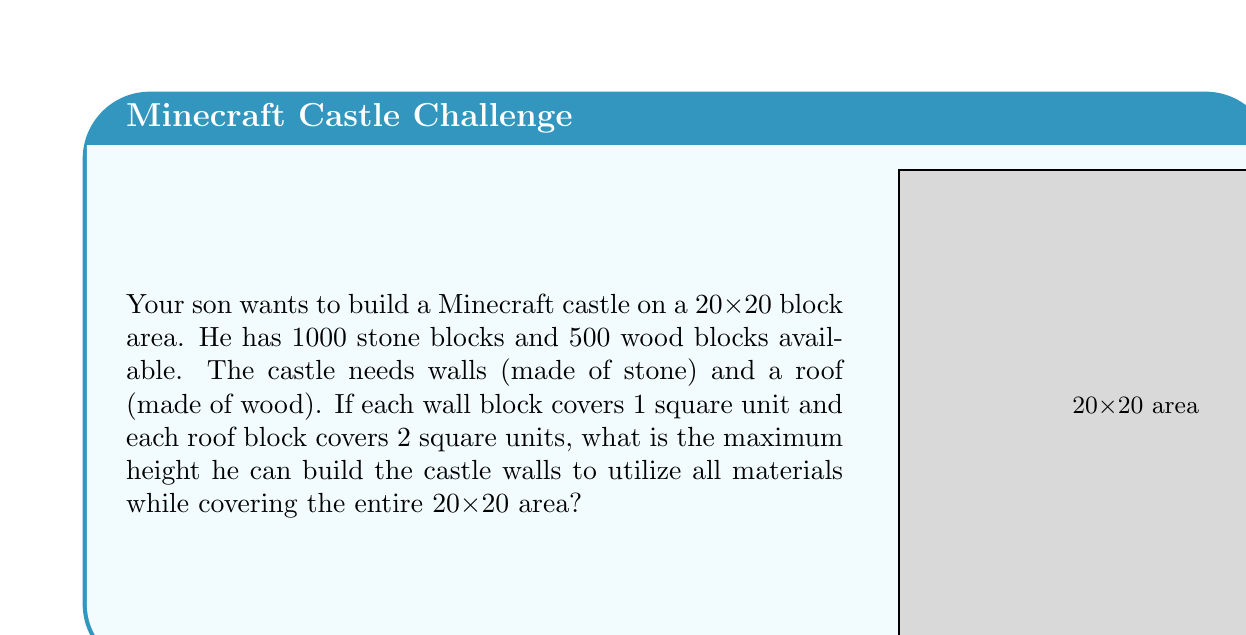Teach me how to tackle this problem. Let's approach this step-by-step:

1) First, we need to calculate the perimeter of the castle to determine how many stone blocks are needed for each level of the wall:
   Perimeter = $4 * 20 = 80$ blocks

2) Now, let's define the height of the castle as $h$. The total number of stone blocks used will be:
   $80h = 1000$

3) Solving for $h$:
   $h = 1000 / 80 = 12.5$

4) Since we can't have a fractional height, we round down to 12 blocks high.

5) Now, let's check if we have enough wood blocks for the roof:
   Area of the roof = $20 * 20 = 400$ square units
   Wood blocks needed = $400 / 2 = 200$ (since each wood block covers 2 square units)

6) We have 500 wood blocks available, which is more than enough for the roof.

7) Let's verify our stone block usage:
   Stone blocks used = $80 * 12 = 960$
   This is less than our available 1000 blocks, but it's the maximum whole number height possible.

Therefore, the maximum height the castle walls can be built is 12 blocks.
Answer: 12 blocks 